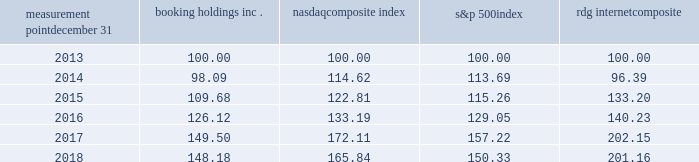Measurement point december 31 booking holdings nasdaq composite index s&p 500 rdg internet composite .

What was the percent of growth of the nasdaq composite index from 2015 to 2016? 
Rationale: the nasdaq composite index increased by 8.5% from 2015 to 2016
Computations: ((133.19 - 122.81) / 122.81)
Answer: 0.08452. 